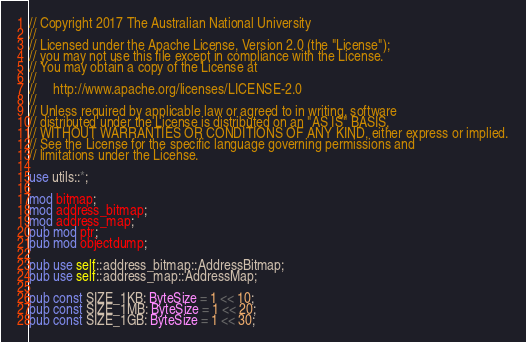Convert code to text. <code><loc_0><loc_0><loc_500><loc_500><_Rust_>// Copyright 2017 The Australian National University
//
// Licensed under the Apache License, Version 2.0 (the "License");
// you may not use this file except in compliance with the License.
// You may obtain a copy of the License at
//
//     http://www.apache.org/licenses/LICENSE-2.0
//
// Unless required by applicable law or agreed to in writing, software
// distributed under the License is distributed on an "AS IS" BASIS,
// WITHOUT WARRANTIES OR CONDITIONS OF ANY KIND, either express or implied.
// See the License for the specific language governing permissions and
// limitations under the License.

use utils::*;

mod bitmap;
mod address_bitmap;
mod address_map;
pub mod ptr;
pub mod objectdump;

pub use self::address_bitmap::AddressBitmap;
pub use self::address_map::AddressMap;

pub const SIZE_1KB: ByteSize = 1 << 10;
pub const SIZE_1MB: ByteSize = 1 << 20;
pub const SIZE_1GB: ByteSize = 1 << 30;
</code> 